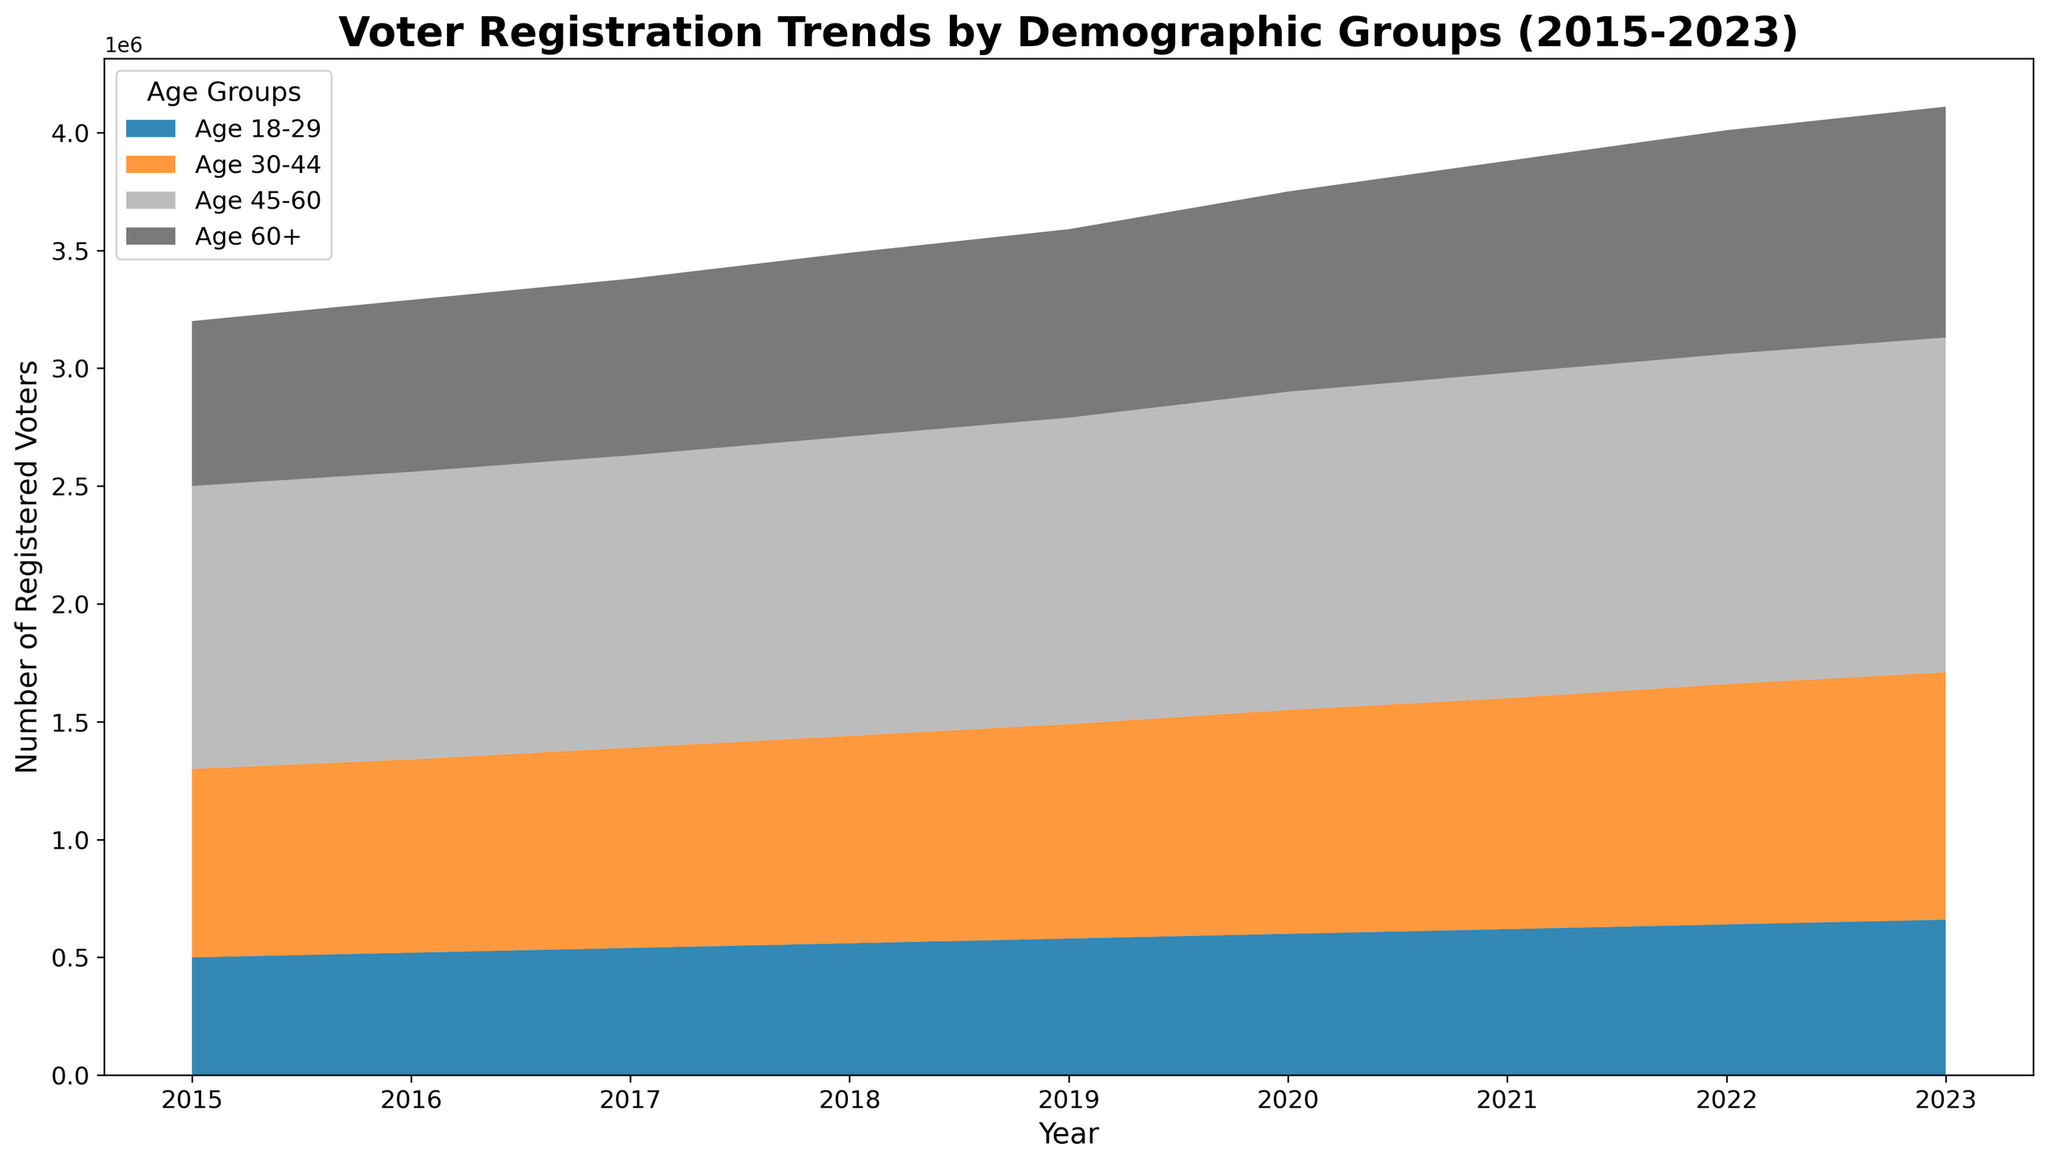What is the total number of registered voters in the year 2020? Sum the number of registered voters across all age groups for the year 2020. The values are 600,000 (Age 18-29), 950,000 (Age 30-44), 1,350,000 (Age 45-60), and 850,000 (Age 60+). The total is 600,000 + 950,000 + 1,350,000 + 850,000 = 3,750,000.
Answer: 3,750,000 Which demographic group showed the highest increase in voter registration from 2015 to 2023? Calculate the difference in voter registration for each age group between 2015 and 2023. For Age 18-29: 660,000 - 500,000 = 160,000. For Age 30-44: 1,050,000 - 800,000 = 250,000. For Age 45-60: 1,420,000 - 1,200,000 = 220,000. For Age 60+: 980,000 - 700,000 = 280,000. The highest increase is in the Age 60+ group with an increase of 280,000.
Answer: Age 60+ Which age group had the least number of registered voters in 2023? Compare the number of registered voters in 2023 across all age groups. The values are 660,000 (Age 18-29), 1,050,000 (Age 30-44), 1,420,000 (Age 45-60), and 980,000 (Age 60+). The least number of registered voters is in the Age 18-29 group.
Answer: Age 18-29 By how much did the number of registered voters in the Age 30-44 group increase from 2018 to 2023? Calculate the difference in the number of registered voters in the Age 30-44 group between 2018 and 2023. The values are 1,050,000 (2023) and 880,000 (2018). The percentage increase is 1,050,000 - 880,000 = 170,000.
Answer: 170,000 What is the average number of registered voters for the Age 60+ group over the period 2015 to 2023? Sum the number of registered voters for the Age 60+ group for each year from 2015 to 2023 and then divide by the number of years (9). The values are 700,000, 730,000, 750,000, 780,000, 800,000, 850,000, 900,000, 950,000, and 980,000. The sum is 7,440,000. The average is 7,440,000 / 9 ≈ 826,667.
Answer: 826,667 